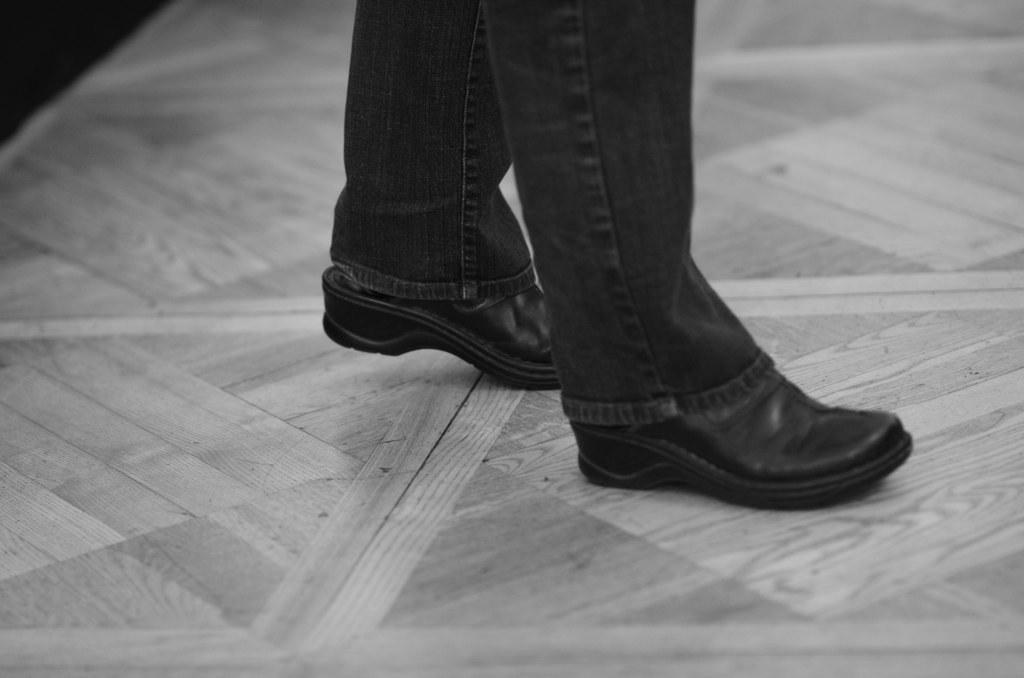Can you describe this image briefly? This image consists of a person wearing a jeans pant and black shoes. At the bottom, there is a floor. It looks like it is made up of wood. 